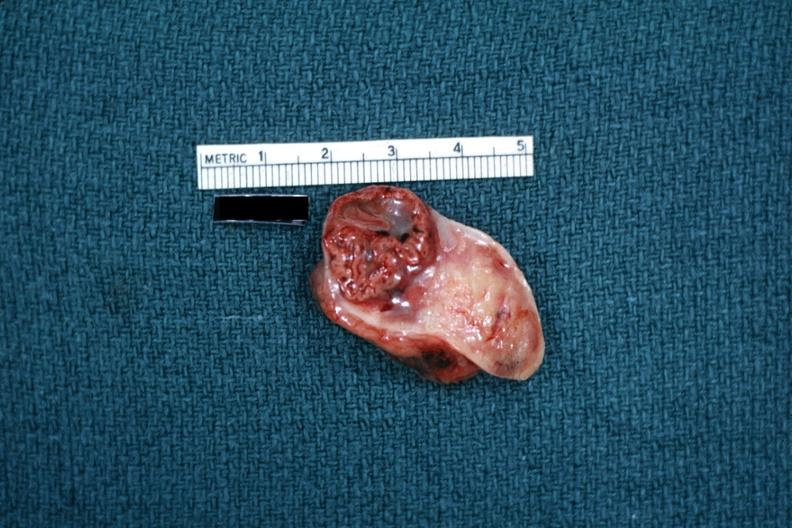s ovary present?
Answer the question using a single word or phrase. Yes 